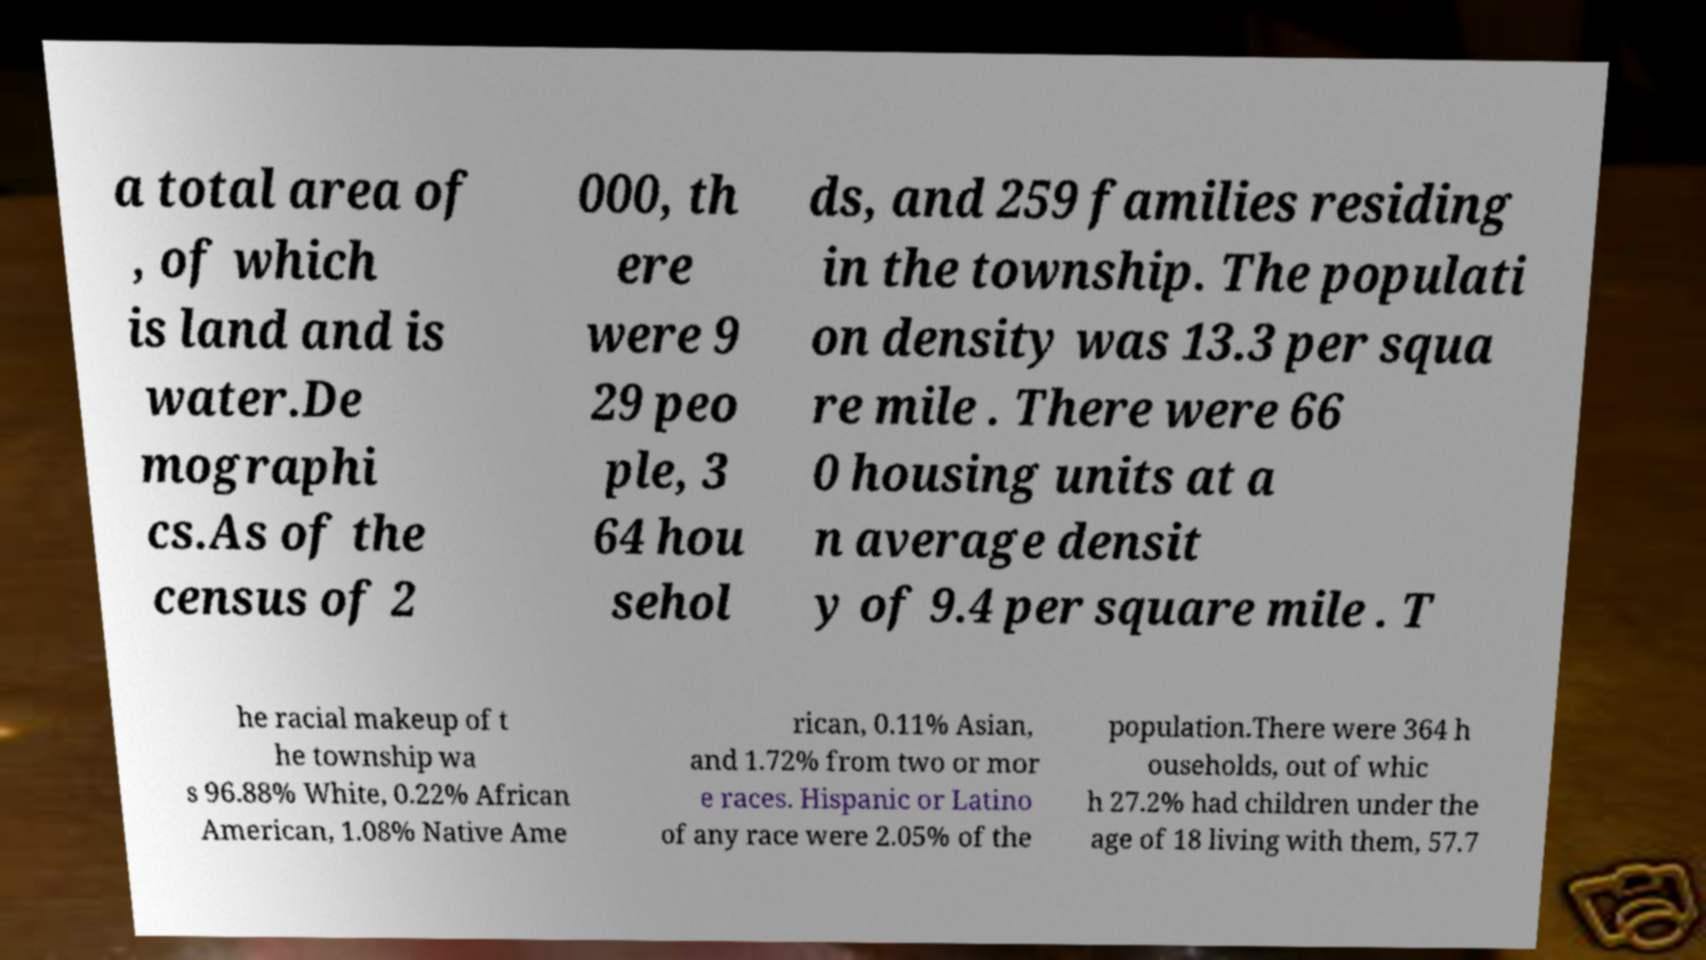Can you accurately transcribe the text from the provided image for me? a total area of , of which is land and is water.De mographi cs.As of the census of 2 000, th ere were 9 29 peo ple, 3 64 hou sehol ds, and 259 families residing in the township. The populati on density was 13.3 per squa re mile . There were 66 0 housing units at a n average densit y of 9.4 per square mile . T he racial makeup of t he township wa s 96.88% White, 0.22% African American, 1.08% Native Ame rican, 0.11% Asian, and 1.72% from two or mor e races. Hispanic or Latino of any race were 2.05% of the population.There were 364 h ouseholds, out of whic h 27.2% had children under the age of 18 living with them, 57.7 